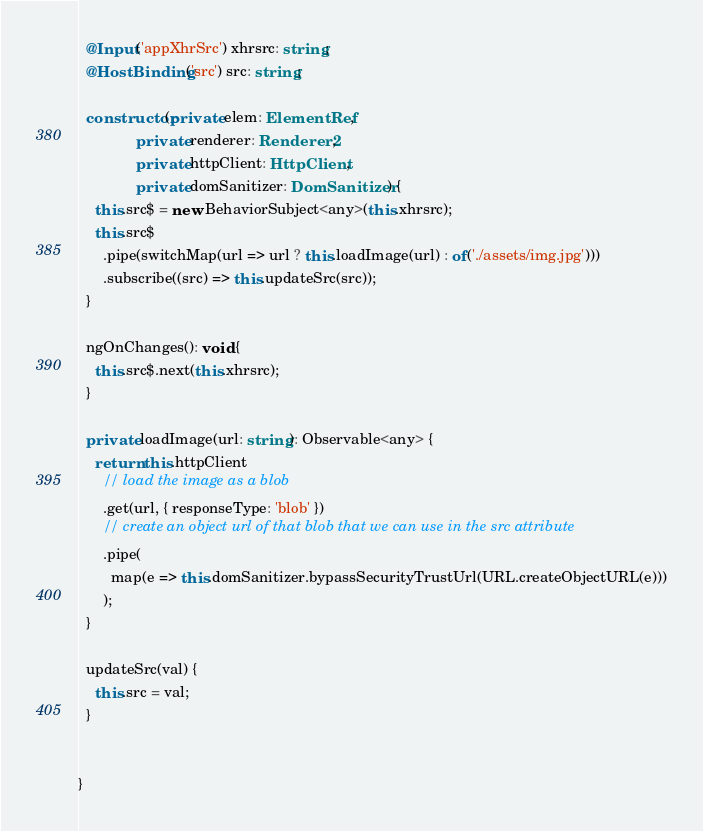<code> <loc_0><loc_0><loc_500><loc_500><_TypeScript_>  @Input('appXhrSrc') xhrsrc: string;
  @HostBinding('src') src: string;

  constructor(private elem: ElementRef,
              private renderer: Renderer2,
              private httpClient: HttpClient,
              private domSanitizer: DomSanitizer) {
    this.src$ = new BehaviorSubject<any>(this.xhrsrc);
    this.src$
      .pipe(switchMap(url => url ? this.loadImage(url) : of('./assets/img.jpg')))
      .subscribe((src) => this.updateSrc(src));
  }

  ngOnChanges(): void {
    this.src$.next(this.xhrsrc);
  }

  private loadImage(url: string): Observable<any> {
    return this.httpClient
      // load the image as a blob
      .get(url, { responseType: 'blob' })
      // create an object url of that blob that we can use in the src attribute
      .pipe(
        map(e => this.domSanitizer.bypassSecurityTrustUrl(URL.createObjectURL(e)))
      );
  }

  updateSrc(val) {
    this.src = val;
  }


}
</code> 